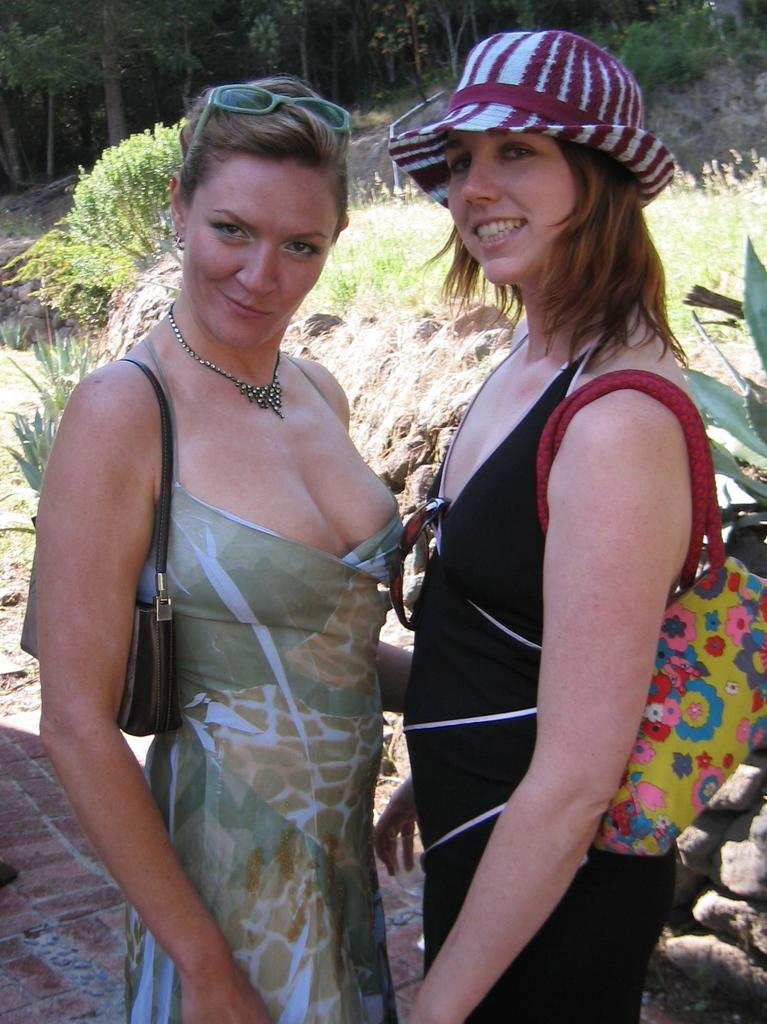How many women are in the image? There are two women in the image. What are the women doing in the image? The women are standing and smiling. What are the women holding in the image? The women are holding bags. What can be seen in the background of the image? There are plants and trees in the background of the image. What is the title of the book the women are reading in the image? There is no book present in the image, so there is no title to reference. 